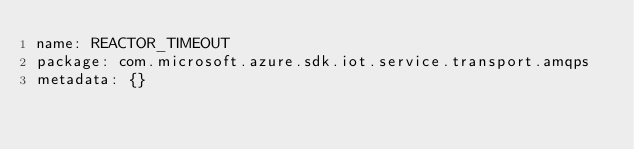<code> <loc_0><loc_0><loc_500><loc_500><_YAML_>name: REACTOR_TIMEOUT
package: com.microsoft.azure.sdk.iot.service.transport.amqps
metadata: {}
</code> 